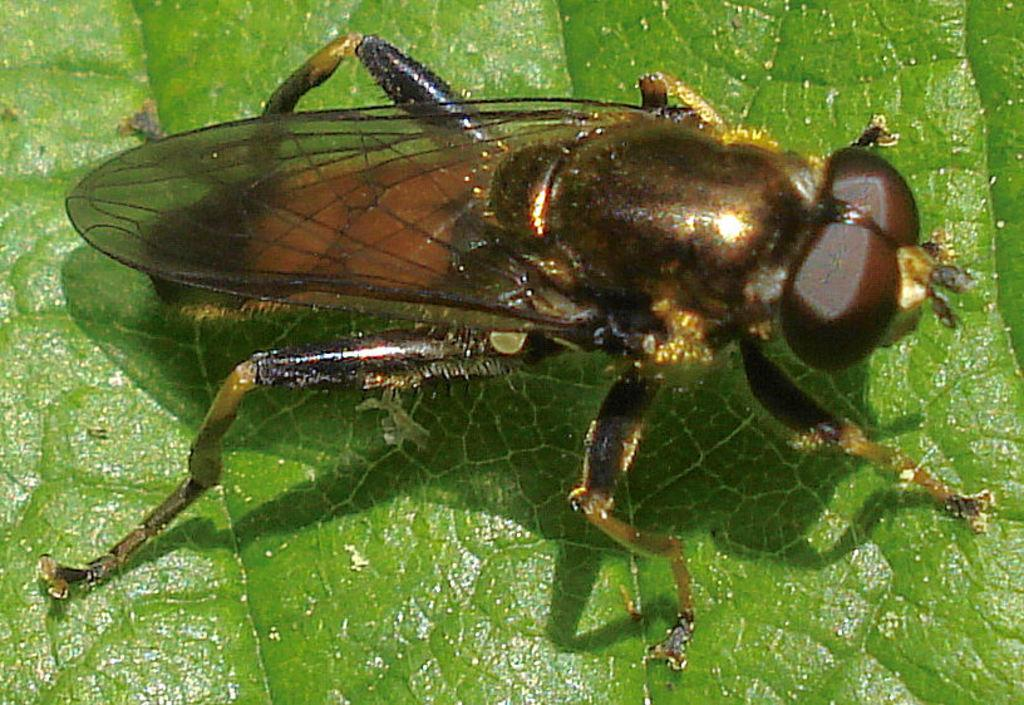What is present on the green leaf in the image? There is an insect on the green leaf in the image. Can you describe the setting in which the insect is located? The insect is on a green leaf. What type of adjustment does the insect need to make in order to perform the trick in the image? There is no trick or adjustment being performed by the insect in the image; it is simply located on a green leaf. 